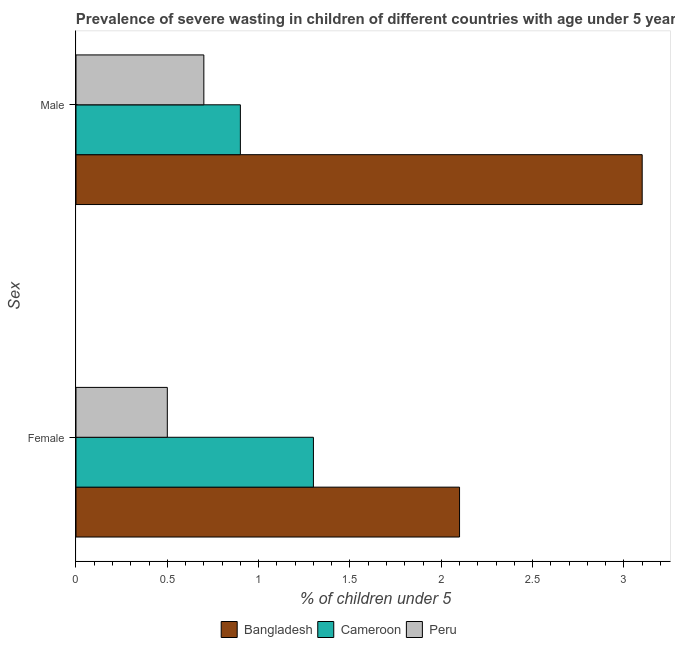How many different coloured bars are there?
Provide a short and direct response. 3. Are the number of bars per tick equal to the number of legend labels?
Offer a very short reply. Yes. How many bars are there on the 2nd tick from the top?
Keep it short and to the point. 3. How many bars are there on the 2nd tick from the bottom?
Give a very brief answer. 3. What is the percentage of undernourished female children in Bangladesh?
Offer a very short reply. 2.1. Across all countries, what is the maximum percentage of undernourished male children?
Make the answer very short. 3.1. Across all countries, what is the minimum percentage of undernourished female children?
Offer a terse response. 0.5. What is the total percentage of undernourished male children in the graph?
Make the answer very short. 4.7. What is the difference between the percentage of undernourished female children in Bangladesh and that in Peru?
Your response must be concise. 1.6. What is the difference between the percentage of undernourished male children in Peru and the percentage of undernourished female children in Cameroon?
Your answer should be compact. -0.6. What is the average percentage of undernourished female children per country?
Make the answer very short. 1.3. What is the difference between the percentage of undernourished male children and percentage of undernourished female children in Peru?
Ensure brevity in your answer.  0.2. In how many countries, is the percentage of undernourished female children greater than 0.30000000000000004 %?
Keep it short and to the point. 3. What is the ratio of the percentage of undernourished male children in Peru to that in Bangladesh?
Offer a terse response. 0.23. In how many countries, is the percentage of undernourished female children greater than the average percentage of undernourished female children taken over all countries?
Keep it short and to the point. 1. What does the 2nd bar from the top in Male represents?
Your answer should be very brief. Cameroon. Are all the bars in the graph horizontal?
Keep it short and to the point. Yes. Are the values on the major ticks of X-axis written in scientific E-notation?
Your answer should be very brief. No. Does the graph contain grids?
Ensure brevity in your answer.  No. Where does the legend appear in the graph?
Your response must be concise. Bottom center. What is the title of the graph?
Give a very brief answer. Prevalence of severe wasting in children of different countries with age under 5 years. Does "Mauritania" appear as one of the legend labels in the graph?
Ensure brevity in your answer.  No. What is the label or title of the X-axis?
Provide a succinct answer.  % of children under 5. What is the label or title of the Y-axis?
Your response must be concise. Sex. What is the  % of children under 5 of Bangladesh in Female?
Give a very brief answer. 2.1. What is the  % of children under 5 of Cameroon in Female?
Ensure brevity in your answer.  1.3. What is the  % of children under 5 of Peru in Female?
Your answer should be compact. 0.5. What is the  % of children under 5 in Bangladesh in Male?
Your response must be concise. 3.1. What is the  % of children under 5 in Cameroon in Male?
Provide a succinct answer. 0.9. What is the  % of children under 5 in Peru in Male?
Ensure brevity in your answer.  0.7. Across all Sex, what is the maximum  % of children under 5 of Bangladesh?
Make the answer very short. 3.1. Across all Sex, what is the maximum  % of children under 5 in Cameroon?
Ensure brevity in your answer.  1.3. Across all Sex, what is the maximum  % of children under 5 in Peru?
Make the answer very short. 0.7. Across all Sex, what is the minimum  % of children under 5 of Bangladesh?
Your answer should be compact. 2.1. Across all Sex, what is the minimum  % of children under 5 in Cameroon?
Your answer should be compact. 0.9. Across all Sex, what is the minimum  % of children under 5 in Peru?
Provide a succinct answer. 0.5. What is the total  % of children under 5 of Bangladesh in the graph?
Make the answer very short. 5.2. What is the total  % of children under 5 in Cameroon in the graph?
Ensure brevity in your answer.  2.2. What is the difference between the  % of children under 5 of Bangladesh in Female and that in Male?
Your answer should be very brief. -1. What is the difference between the  % of children under 5 of Cameroon in Female and that in Male?
Your response must be concise. 0.4. What is the difference between the  % of children under 5 of Cameroon in Female and the  % of children under 5 of Peru in Male?
Offer a terse response. 0.6. What is the average  % of children under 5 of Cameroon per Sex?
Your response must be concise. 1.1. What is the average  % of children under 5 in Peru per Sex?
Your answer should be compact. 0.6. What is the difference between the  % of children under 5 in Bangladesh and  % of children under 5 in Peru in Female?
Give a very brief answer. 1.6. What is the difference between the  % of children under 5 in Bangladesh and  % of children under 5 in Cameroon in Male?
Your answer should be compact. 2.2. What is the difference between the  % of children under 5 of Cameroon and  % of children under 5 of Peru in Male?
Give a very brief answer. 0.2. What is the ratio of the  % of children under 5 of Bangladesh in Female to that in Male?
Keep it short and to the point. 0.68. What is the ratio of the  % of children under 5 in Cameroon in Female to that in Male?
Give a very brief answer. 1.44. What is the difference between the highest and the second highest  % of children under 5 in Cameroon?
Provide a short and direct response. 0.4. What is the difference between the highest and the lowest  % of children under 5 of Cameroon?
Your response must be concise. 0.4. 